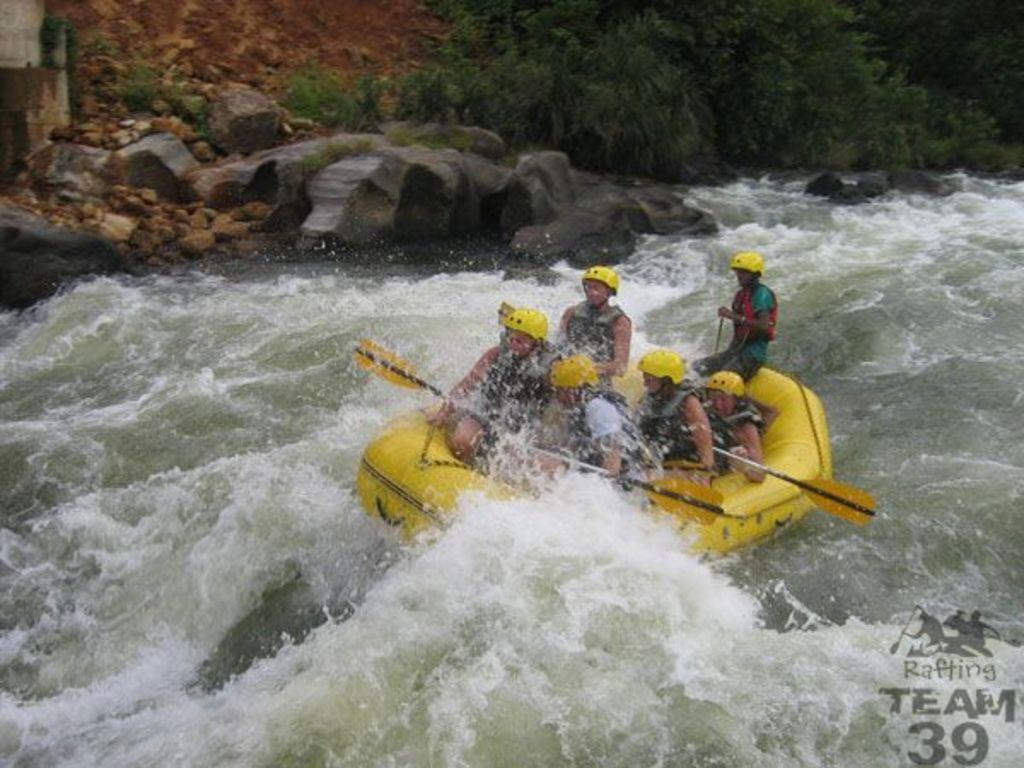How would you summarize this image in a sentence or two? There are few persons riding a boat. This is water. In the background we can see rocks and trees. 